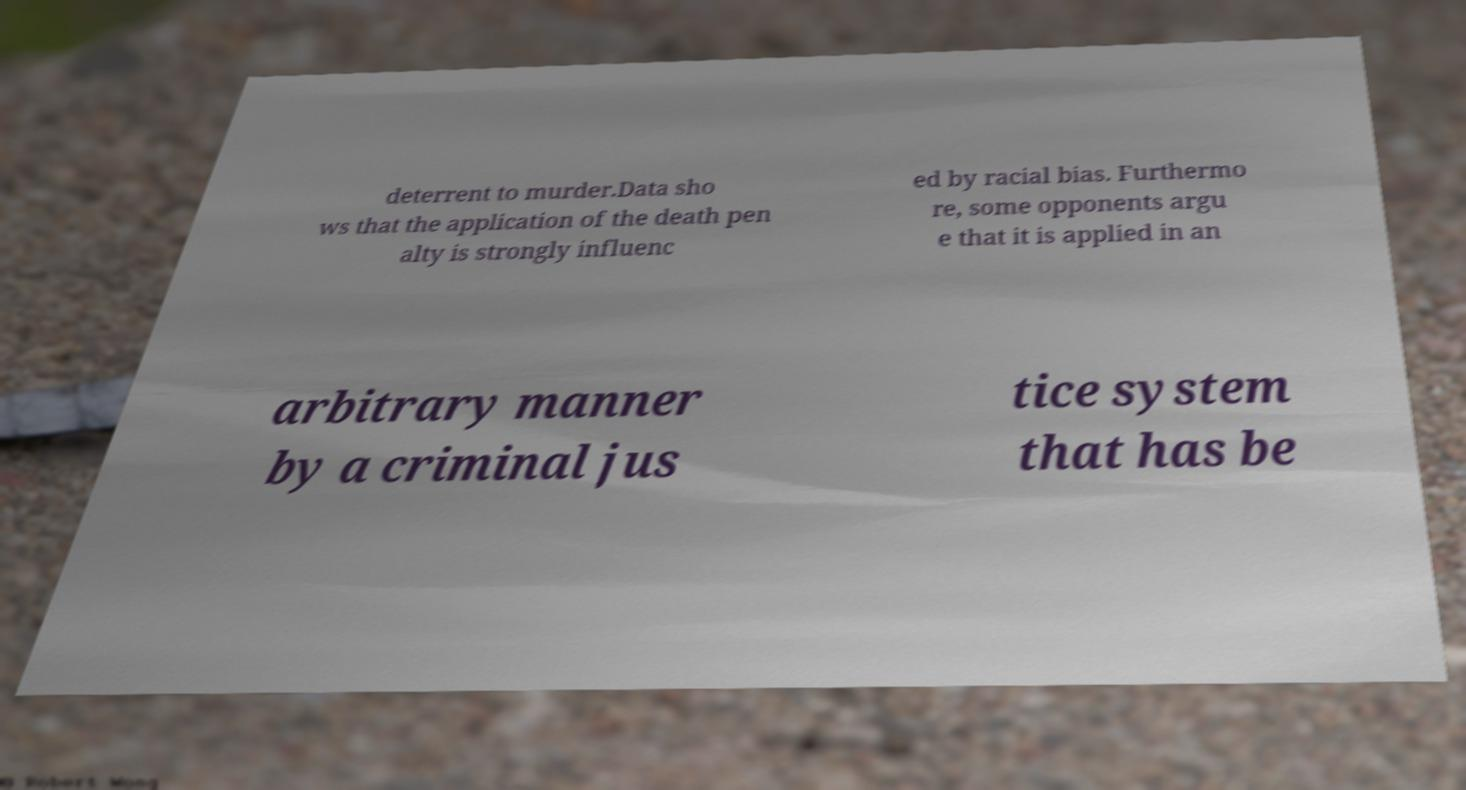Can you read and provide the text displayed in the image?This photo seems to have some interesting text. Can you extract and type it out for me? deterrent to murder.Data sho ws that the application of the death pen alty is strongly influenc ed by racial bias. Furthermo re, some opponents argu e that it is applied in an arbitrary manner by a criminal jus tice system that has be 